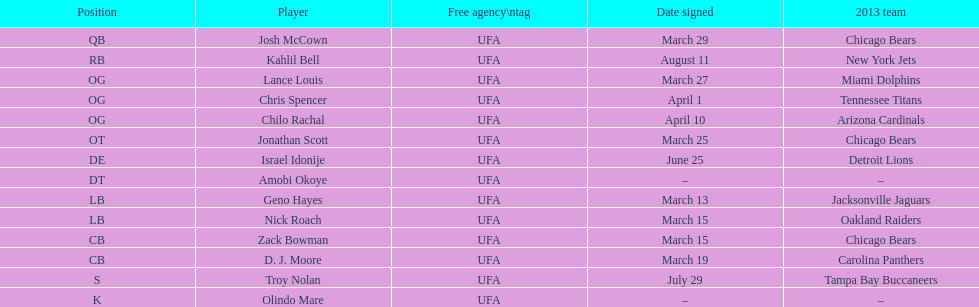Can you name the single player who signed in july? Troy Nolan. 